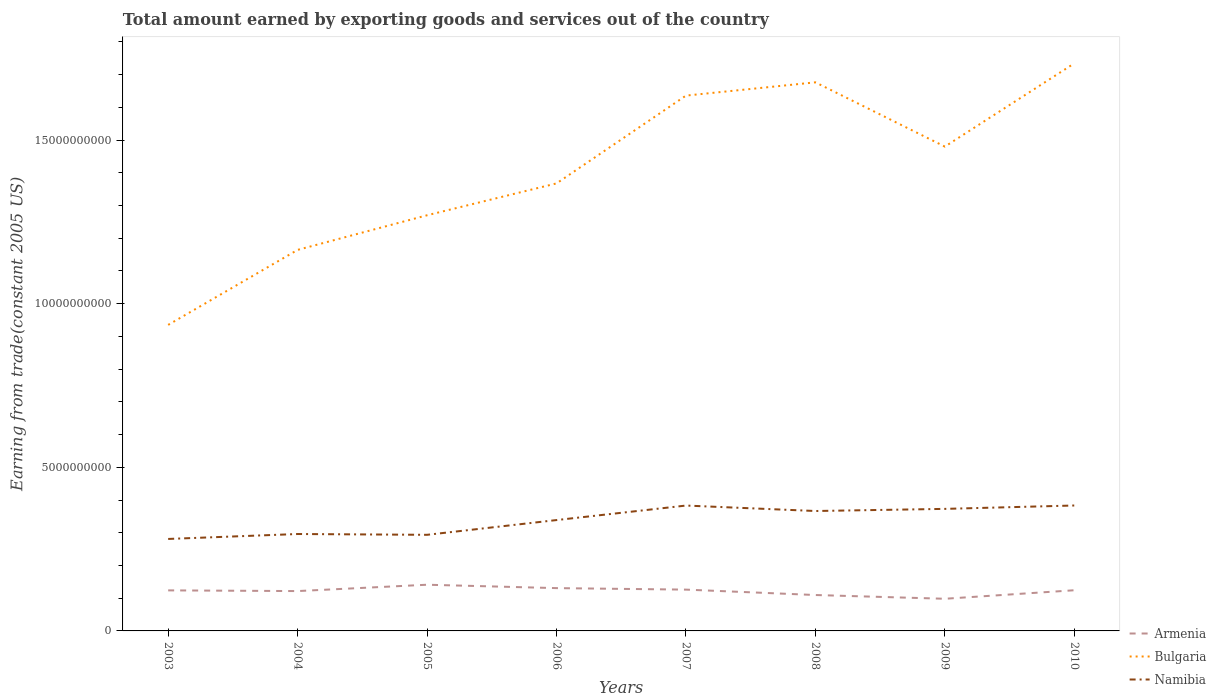How many different coloured lines are there?
Your answer should be compact. 3. Across all years, what is the maximum total amount earned by exporting goods and services in Bulgaria?
Your answer should be compact. 9.35e+09. What is the total total amount earned by exporting goods and services in Namibia in the graph?
Offer a very short reply. -4.51e+08. What is the difference between the highest and the second highest total amount earned by exporting goods and services in Namibia?
Give a very brief answer. 1.02e+09. What is the difference between the highest and the lowest total amount earned by exporting goods and services in Armenia?
Your answer should be compact. 5. How many lines are there?
Keep it short and to the point. 3. How many years are there in the graph?
Keep it short and to the point. 8. Does the graph contain any zero values?
Provide a short and direct response. No. Does the graph contain grids?
Provide a succinct answer. No. How many legend labels are there?
Offer a very short reply. 3. How are the legend labels stacked?
Your answer should be compact. Vertical. What is the title of the graph?
Give a very brief answer. Total amount earned by exporting goods and services out of the country. Does "San Marino" appear as one of the legend labels in the graph?
Your answer should be compact. No. What is the label or title of the X-axis?
Provide a succinct answer. Years. What is the label or title of the Y-axis?
Your answer should be very brief. Earning from trade(constant 2005 US). What is the Earning from trade(constant 2005 US) of Armenia in 2003?
Offer a terse response. 1.24e+09. What is the Earning from trade(constant 2005 US) of Bulgaria in 2003?
Provide a succinct answer. 9.35e+09. What is the Earning from trade(constant 2005 US) of Namibia in 2003?
Offer a very short reply. 2.81e+09. What is the Earning from trade(constant 2005 US) of Armenia in 2004?
Your answer should be very brief. 1.22e+09. What is the Earning from trade(constant 2005 US) of Bulgaria in 2004?
Make the answer very short. 1.16e+1. What is the Earning from trade(constant 2005 US) of Namibia in 2004?
Give a very brief answer. 2.96e+09. What is the Earning from trade(constant 2005 US) of Armenia in 2005?
Your response must be concise. 1.41e+09. What is the Earning from trade(constant 2005 US) in Bulgaria in 2005?
Make the answer very short. 1.27e+1. What is the Earning from trade(constant 2005 US) in Namibia in 2005?
Provide a short and direct response. 2.94e+09. What is the Earning from trade(constant 2005 US) of Armenia in 2006?
Offer a very short reply. 1.31e+09. What is the Earning from trade(constant 2005 US) of Bulgaria in 2006?
Keep it short and to the point. 1.37e+1. What is the Earning from trade(constant 2005 US) of Namibia in 2006?
Provide a short and direct response. 3.39e+09. What is the Earning from trade(constant 2005 US) of Armenia in 2007?
Provide a short and direct response. 1.26e+09. What is the Earning from trade(constant 2005 US) in Bulgaria in 2007?
Offer a very short reply. 1.64e+1. What is the Earning from trade(constant 2005 US) of Namibia in 2007?
Your response must be concise. 3.83e+09. What is the Earning from trade(constant 2005 US) in Armenia in 2008?
Provide a short and direct response. 1.10e+09. What is the Earning from trade(constant 2005 US) of Bulgaria in 2008?
Offer a very short reply. 1.68e+1. What is the Earning from trade(constant 2005 US) of Namibia in 2008?
Make the answer very short. 3.66e+09. What is the Earning from trade(constant 2005 US) in Armenia in 2009?
Provide a short and direct response. 9.83e+08. What is the Earning from trade(constant 2005 US) of Bulgaria in 2009?
Your answer should be very brief. 1.48e+1. What is the Earning from trade(constant 2005 US) of Namibia in 2009?
Provide a short and direct response. 3.73e+09. What is the Earning from trade(constant 2005 US) of Armenia in 2010?
Provide a short and direct response. 1.24e+09. What is the Earning from trade(constant 2005 US) in Bulgaria in 2010?
Make the answer very short. 1.73e+1. What is the Earning from trade(constant 2005 US) in Namibia in 2010?
Offer a terse response. 3.83e+09. Across all years, what is the maximum Earning from trade(constant 2005 US) of Armenia?
Keep it short and to the point. 1.41e+09. Across all years, what is the maximum Earning from trade(constant 2005 US) in Bulgaria?
Provide a succinct answer. 1.73e+1. Across all years, what is the maximum Earning from trade(constant 2005 US) in Namibia?
Offer a terse response. 3.83e+09. Across all years, what is the minimum Earning from trade(constant 2005 US) in Armenia?
Keep it short and to the point. 9.83e+08. Across all years, what is the minimum Earning from trade(constant 2005 US) in Bulgaria?
Offer a very short reply. 9.35e+09. Across all years, what is the minimum Earning from trade(constant 2005 US) of Namibia?
Provide a short and direct response. 2.81e+09. What is the total Earning from trade(constant 2005 US) of Armenia in the graph?
Your response must be concise. 9.76e+09. What is the total Earning from trade(constant 2005 US) of Bulgaria in the graph?
Give a very brief answer. 1.13e+11. What is the total Earning from trade(constant 2005 US) of Namibia in the graph?
Give a very brief answer. 2.72e+1. What is the difference between the Earning from trade(constant 2005 US) of Armenia in 2003 and that in 2004?
Your answer should be compact. 2.14e+07. What is the difference between the Earning from trade(constant 2005 US) in Bulgaria in 2003 and that in 2004?
Provide a succinct answer. -2.29e+09. What is the difference between the Earning from trade(constant 2005 US) in Namibia in 2003 and that in 2004?
Your answer should be compact. -1.51e+08. What is the difference between the Earning from trade(constant 2005 US) in Armenia in 2003 and that in 2005?
Your answer should be very brief. -1.73e+08. What is the difference between the Earning from trade(constant 2005 US) of Bulgaria in 2003 and that in 2005?
Offer a terse response. -3.35e+09. What is the difference between the Earning from trade(constant 2005 US) in Namibia in 2003 and that in 2005?
Your answer should be very brief. -1.26e+08. What is the difference between the Earning from trade(constant 2005 US) in Armenia in 2003 and that in 2006?
Give a very brief answer. -6.90e+07. What is the difference between the Earning from trade(constant 2005 US) in Bulgaria in 2003 and that in 2006?
Provide a succinct answer. -4.32e+09. What is the difference between the Earning from trade(constant 2005 US) in Namibia in 2003 and that in 2006?
Make the answer very short. -5.77e+08. What is the difference between the Earning from trade(constant 2005 US) in Armenia in 2003 and that in 2007?
Provide a succinct answer. -2.31e+07. What is the difference between the Earning from trade(constant 2005 US) of Bulgaria in 2003 and that in 2007?
Make the answer very short. -7.01e+09. What is the difference between the Earning from trade(constant 2005 US) of Namibia in 2003 and that in 2007?
Provide a succinct answer. -1.02e+09. What is the difference between the Earning from trade(constant 2005 US) in Armenia in 2003 and that in 2008?
Ensure brevity in your answer.  1.42e+08. What is the difference between the Earning from trade(constant 2005 US) in Bulgaria in 2003 and that in 2008?
Keep it short and to the point. -7.41e+09. What is the difference between the Earning from trade(constant 2005 US) in Namibia in 2003 and that in 2008?
Your answer should be compact. -8.54e+08. What is the difference between the Earning from trade(constant 2005 US) of Armenia in 2003 and that in 2009?
Provide a succinct answer. 2.56e+08. What is the difference between the Earning from trade(constant 2005 US) in Bulgaria in 2003 and that in 2009?
Offer a terse response. -5.45e+09. What is the difference between the Earning from trade(constant 2005 US) in Namibia in 2003 and that in 2009?
Offer a very short reply. -9.19e+08. What is the difference between the Earning from trade(constant 2005 US) of Armenia in 2003 and that in 2010?
Offer a very short reply. -3.95e+06. What is the difference between the Earning from trade(constant 2005 US) of Bulgaria in 2003 and that in 2010?
Provide a short and direct response. -7.99e+09. What is the difference between the Earning from trade(constant 2005 US) in Namibia in 2003 and that in 2010?
Your response must be concise. -1.02e+09. What is the difference between the Earning from trade(constant 2005 US) of Armenia in 2004 and that in 2005?
Give a very brief answer. -1.94e+08. What is the difference between the Earning from trade(constant 2005 US) of Bulgaria in 2004 and that in 2005?
Provide a succinct answer. -1.06e+09. What is the difference between the Earning from trade(constant 2005 US) in Namibia in 2004 and that in 2005?
Your response must be concise. 2.46e+07. What is the difference between the Earning from trade(constant 2005 US) in Armenia in 2004 and that in 2006?
Make the answer very short. -9.05e+07. What is the difference between the Earning from trade(constant 2005 US) of Bulgaria in 2004 and that in 2006?
Provide a short and direct response. -2.03e+09. What is the difference between the Earning from trade(constant 2005 US) in Namibia in 2004 and that in 2006?
Offer a terse response. -4.26e+08. What is the difference between the Earning from trade(constant 2005 US) of Armenia in 2004 and that in 2007?
Offer a very short reply. -4.46e+07. What is the difference between the Earning from trade(constant 2005 US) in Bulgaria in 2004 and that in 2007?
Provide a succinct answer. -4.72e+09. What is the difference between the Earning from trade(constant 2005 US) in Namibia in 2004 and that in 2007?
Your response must be concise. -8.70e+08. What is the difference between the Earning from trade(constant 2005 US) in Armenia in 2004 and that in 2008?
Keep it short and to the point. 1.21e+08. What is the difference between the Earning from trade(constant 2005 US) in Bulgaria in 2004 and that in 2008?
Your answer should be very brief. -5.12e+09. What is the difference between the Earning from trade(constant 2005 US) in Namibia in 2004 and that in 2008?
Offer a terse response. -7.03e+08. What is the difference between the Earning from trade(constant 2005 US) of Armenia in 2004 and that in 2009?
Your answer should be compact. 2.35e+08. What is the difference between the Earning from trade(constant 2005 US) in Bulgaria in 2004 and that in 2009?
Give a very brief answer. -3.16e+09. What is the difference between the Earning from trade(constant 2005 US) of Namibia in 2004 and that in 2009?
Make the answer very short. -7.68e+08. What is the difference between the Earning from trade(constant 2005 US) of Armenia in 2004 and that in 2010?
Offer a very short reply. -2.54e+07. What is the difference between the Earning from trade(constant 2005 US) of Bulgaria in 2004 and that in 2010?
Offer a very short reply. -5.70e+09. What is the difference between the Earning from trade(constant 2005 US) in Namibia in 2004 and that in 2010?
Offer a very short reply. -8.71e+08. What is the difference between the Earning from trade(constant 2005 US) of Armenia in 2005 and that in 2006?
Your answer should be very brief. 1.04e+08. What is the difference between the Earning from trade(constant 2005 US) in Bulgaria in 2005 and that in 2006?
Your response must be concise. -9.73e+08. What is the difference between the Earning from trade(constant 2005 US) of Namibia in 2005 and that in 2006?
Your answer should be compact. -4.51e+08. What is the difference between the Earning from trade(constant 2005 US) of Armenia in 2005 and that in 2007?
Offer a terse response. 1.50e+08. What is the difference between the Earning from trade(constant 2005 US) of Bulgaria in 2005 and that in 2007?
Offer a terse response. -3.66e+09. What is the difference between the Earning from trade(constant 2005 US) of Namibia in 2005 and that in 2007?
Make the answer very short. -8.94e+08. What is the difference between the Earning from trade(constant 2005 US) in Armenia in 2005 and that in 2008?
Make the answer very short. 3.15e+08. What is the difference between the Earning from trade(constant 2005 US) in Bulgaria in 2005 and that in 2008?
Provide a succinct answer. -4.06e+09. What is the difference between the Earning from trade(constant 2005 US) in Namibia in 2005 and that in 2008?
Keep it short and to the point. -7.27e+08. What is the difference between the Earning from trade(constant 2005 US) in Armenia in 2005 and that in 2009?
Your answer should be compact. 4.29e+08. What is the difference between the Earning from trade(constant 2005 US) in Bulgaria in 2005 and that in 2009?
Offer a terse response. -2.10e+09. What is the difference between the Earning from trade(constant 2005 US) of Namibia in 2005 and that in 2009?
Provide a succinct answer. -7.93e+08. What is the difference between the Earning from trade(constant 2005 US) of Armenia in 2005 and that in 2010?
Your answer should be very brief. 1.69e+08. What is the difference between the Earning from trade(constant 2005 US) in Bulgaria in 2005 and that in 2010?
Give a very brief answer. -4.64e+09. What is the difference between the Earning from trade(constant 2005 US) of Namibia in 2005 and that in 2010?
Make the answer very short. -8.96e+08. What is the difference between the Earning from trade(constant 2005 US) of Armenia in 2006 and that in 2007?
Your response must be concise. 4.59e+07. What is the difference between the Earning from trade(constant 2005 US) in Bulgaria in 2006 and that in 2007?
Your answer should be very brief. -2.68e+09. What is the difference between the Earning from trade(constant 2005 US) of Namibia in 2006 and that in 2007?
Your answer should be very brief. -4.44e+08. What is the difference between the Earning from trade(constant 2005 US) of Armenia in 2006 and that in 2008?
Offer a terse response. 2.11e+08. What is the difference between the Earning from trade(constant 2005 US) of Bulgaria in 2006 and that in 2008?
Provide a succinct answer. -3.09e+09. What is the difference between the Earning from trade(constant 2005 US) in Namibia in 2006 and that in 2008?
Provide a short and direct response. -2.77e+08. What is the difference between the Earning from trade(constant 2005 US) in Armenia in 2006 and that in 2009?
Give a very brief answer. 3.25e+08. What is the difference between the Earning from trade(constant 2005 US) in Bulgaria in 2006 and that in 2009?
Ensure brevity in your answer.  -1.12e+09. What is the difference between the Earning from trade(constant 2005 US) in Namibia in 2006 and that in 2009?
Give a very brief answer. -3.42e+08. What is the difference between the Earning from trade(constant 2005 US) of Armenia in 2006 and that in 2010?
Ensure brevity in your answer.  6.51e+07. What is the difference between the Earning from trade(constant 2005 US) of Bulgaria in 2006 and that in 2010?
Provide a succinct answer. -3.67e+09. What is the difference between the Earning from trade(constant 2005 US) in Namibia in 2006 and that in 2010?
Provide a short and direct response. -4.45e+08. What is the difference between the Earning from trade(constant 2005 US) in Armenia in 2007 and that in 2008?
Your answer should be compact. 1.65e+08. What is the difference between the Earning from trade(constant 2005 US) in Bulgaria in 2007 and that in 2008?
Offer a very short reply. -4.05e+08. What is the difference between the Earning from trade(constant 2005 US) in Namibia in 2007 and that in 2008?
Give a very brief answer. 1.67e+08. What is the difference between the Earning from trade(constant 2005 US) in Armenia in 2007 and that in 2009?
Provide a succinct answer. 2.80e+08. What is the difference between the Earning from trade(constant 2005 US) in Bulgaria in 2007 and that in 2009?
Provide a succinct answer. 1.56e+09. What is the difference between the Earning from trade(constant 2005 US) of Namibia in 2007 and that in 2009?
Offer a very short reply. 1.02e+08. What is the difference between the Earning from trade(constant 2005 US) in Armenia in 2007 and that in 2010?
Give a very brief answer. 1.92e+07. What is the difference between the Earning from trade(constant 2005 US) of Bulgaria in 2007 and that in 2010?
Offer a very short reply. -9.86e+08. What is the difference between the Earning from trade(constant 2005 US) of Namibia in 2007 and that in 2010?
Provide a short and direct response. -1.66e+06. What is the difference between the Earning from trade(constant 2005 US) in Armenia in 2008 and that in 2009?
Provide a succinct answer. 1.14e+08. What is the difference between the Earning from trade(constant 2005 US) of Bulgaria in 2008 and that in 2009?
Provide a short and direct response. 1.96e+09. What is the difference between the Earning from trade(constant 2005 US) in Namibia in 2008 and that in 2009?
Make the answer very short. -6.54e+07. What is the difference between the Earning from trade(constant 2005 US) in Armenia in 2008 and that in 2010?
Make the answer very short. -1.46e+08. What is the difference between the Earning from trade(constant 2005 US) in Bulgaria in 2008 and that in 2010?
Provide a succinct answer. -5.80e+08. What is the difference between the Earning from trade(constant 2005 US) of Namibia in 2008 and that in 2010?
Your response must be concise. -1.69e+08. What is the difference between the Earning from trade(constant 2005 US) in Armenia in 2009 and that in 2010?
Your response must be concise. -2.60e+08. What is the difference between the Earning from trade(constant 2005 US) of Bulgaria in 2009 and that in 2010?
Provide a succinct answer. -2.54e+09. What is the difference between the Earning from trade(constant 2005 US) of Namibia in 2009 and that in 2010?
Keep it short and to the point. -1.03e+08. What is the difference between the Earning from trade(constant 2005 US) of Armenia in 2003 and the Earning from trade(constant 2005 US) of Bulgaria in 2004?
Provide a short and direct response. -1.04e+1. What is the difference between the Earning from trade(constant 2005 US) of Armenia in 2003 and the Earning from trade(constant 2005 US) of Namibia in 2004?
Your answer should be very brief. -1.72e+09. What is the difference between the Earning from trade(constant 2005 US) of Bulgaria in 2003 and the Earning from trade(constant 2005 US) of Namibia in 2004?
Give a very brief answer. 6.39e+09. What is the difference between the Earning from trade(constant 2005 US) in Armenia in 2003 and the Earning from trade(constant 2005 US) in Bulgaria in 2005?
Provide a succinct answer. -1.15e+1. What is the difference between the Earning from trade(constant 2005 US) of Armenia in 2003 and the Earning from trade(constant 2005 US) of Namibia in 2005?
Offer a very short reply. -1.70e+09. What is the difference between the Earning from trade(constant 2005 US) of Bulgaria in 2003 and the Earning from trade(constant 2005 US) of Namibia in 2005?
Provide a succinct answer. 6.42e+09. What is the difference between the Earning from trade(constant 2005 US) of Armenia in 2003 and the Earning from trade(constant 2005 US) of Bulgaria in 2006?
Your answer should be very brief. -1.24e+1. What is the difference between the Earning from trade(constant 2005 US) in Armenia in 2003 and the Earning from trade(constant 2005 US) in Namibia in 2006?
Keep it short and to the point. -2.15e+09. What is the difference between the Earning from trade(constant 2005 US) in Bulgaria in 2003 and the Earning from trade(constant 2005 US) in Namibia in 2006?
Provide a short and direct response. 5.97e+09. What is the difference between the Earning from trade(constant 2005 US) of Armenia in 2003 and the Earning from trade(constant 2005 US) of Bulgaria in 2007?
Your response must be concise. -1.51e+1. What is the difference between the Earning from trade(constant 2005 US) of Armenia in 2003 and the Earning from trade(constant 2005 US) of Namibia in 2007?
Your response must be concise. -2.59e+09. What is the difference between the Earning from trade(constant 2005 US) in Bulgaria in 2003 and the Earning from trade(constant 2005 US) in Namibia in 2007?
Provide a short and direct response. 5.52e+09. What is the difference between the Earning from trade(constant 2005 US) in Armenia in 2003 and the Earning from trade(constant 2005 US) in Bulgaria in 2008?
Your answer should be very brief. -1.55e+1. What is the difference between the Earning from trade(constant 2005 US) of Armenia in 2003 and the Earning from trade(constant 2005 US) of Namibia in 2008?
Your response must be concise. -2.43e+09. What is the difference between the Earning from trade(constant 2005 US) in Bulgaria in 2003 and the Earning from trade(constant 2005 US) in Namibia in 2008?
Give a very brief answer. 5.69e+09. What is the difference between the Earning from trade(constant 2005 US) in Armenia in 2003 and the Earning from trade(constant 2005 US) in Bulgaria in 2009?
Offer a very short reply. -1.36e+1. What is the difference between the Earning from trade(constant 2005 US) of Armenia in 2003 and the Earning from trade(constant 2005 US) of Namibia in 2009?
Provide a short and direct response. -2.49e+09. What is the difference between the Earning from trade(constant 2005 US) in Bulgaria in 2003 and the Earning from trade(constant 2005 US) in Namibia in 2009?
Provide a succinct answer. 5.62e+09. What is the difference between the Earning from trade(constant 2005 US) of Armenia in 2003 and the Earning from trade(constant 2005 US) of Bulgaria in 2010?
Provide a short and direct response. -1.61e+1. What is the difference between the Earning from trade(constant 2005 US) in Armenia in 2003 and the Earning from trade(constant 2005 US) in Namibia in 2010?
Give a very brief answer. -2.59e+09. What is the difference between the Earning from trade(constant 2005 US) of Bulgaria in 2003 and the Earning from trade(constant 2005 US) of Namibia in 2010?
Your answer should be compact. 5.52e+09. What is the difference between the Earning from trade(constant 2005 US) in Armenia in 2004 and the Earning from trade(constant 2005 US) in Bulgaria in 2005?
Your answer should be compact. -1.15e+1. What is the difference between the Earning from trade(constant 2005 US) in Armenia in 2004 and the Earning from trade(constant 2005 US) in Namibia in 2005?
Offer a very short reply. -1.72e+09. What is the difference between the Earning from trade(constant 2005 US) of Bulgaria in 2004 and the Earning from trade(constant 2005 US) of Namibia in 2005?
Make the answer very short. 8.71e+09. What is the difference between the Earning from trade(constant 2005 US) of Armenia in 2004 and the Earning from trade(constant 2005 US) of Bulgaria in 2006?
Make the answer very short. -1.25e+1. What is the difference between the Earning from trade(constant 2005 US) of Armenia in 2004 and the Earning from trade(constant 2005 US) of Namibia in 2006?
Offer a terse response. -2.17e+09. What is the difference between the Earning from trade(constant 2005 US) in Bulgaria in 2004 and the Earning from trade(constant 2005 US) in Namibia in 2006?
Your answer should be compact. 8.26e+09. What is the difference between the Earning from trade(constant 2005 US) in Armenia in 2004 and the Earning from trade(constant 2005 US) in Bulgaria in 2007?
Your answer should be very brief. -1.51e+1. What is the difference between the Earning from trade(constant 2005 US) in Armenia in 2004 and the Earning from trade(constant 2005 US) in Namibia in 2007?
Make the answer very short. -2.61e+09. What is the difference between the Earning from trade(constant 2005 US) in Bulgaria in 2004 and the Earning from trade(constant 2005 US) in Namibia in 2007?
Provide a short and direct response. 7.81e+09. What is the difference between the Earning from trade(constant 2005 US) of Armenia in 2004 and the Earning from trade(constant 2005 US) of Bulgaria in 2008?
Offer a very short reply. -1.55e+1. What is the difference between the Earning from trade(constant 2005 US) in Armenia in 2004 and the Earning from trade(constant 2005 US) in Namibia in 2008?
Make the answer very short. -2.45e+09. What is the difference between the Earning from trade(constant 2005 US) of Bulgaria in 2004 and the Earning from trade(constant 2005 US) of Namibia in 2008?
Your answer should be compact. 7.98e+09. What is the difference between the Earning from trade(constant 2005 US) in Armenia in 2004 and the Earning from trade(constant 2005 US) in Bulgaria in 2009?
Your answer should be very brief. -1.36e+1. What is the difference between the Earning from trade(constant 2005 US) in Armenia in 2004 and the Earning from trade(constant 2005 US) in Namibia in 2009?
Give a very brief answer. -2.51e+09. What is the difference between the Earning from trade(constant 2005 US) in Bulgaria in 2004 and the Earning from trade(constant 2005 US) in Namibia in 2009?
Your response must be concise. 7.92e+09. What is the difference between the Earning from trade(constant 2005 US) of Armenia in 2004 and the Earning from trade(constant 2005 US) of Bulgaria in 2010?
Offer a terse response. -1.61e+1. What is the difference between the Earning from trade(constant 2005 US) in Armenia in 2004 and the Earning from trade(constant 2005 US) in Namibia in 2010?
Your answer should be compact. -2.62e+09. What is the difference between the Earning from trade(constant 2005 US) of Bulgaria in 2004 and the Earning from trade(constant 2005 US) of Namibia in 2010?
Offer a very short reply. 7.81e+09. What is the difference between the Earning from trade(constant 2005 US) in Armenia in 2005 and the Earning from trade(constant 2005 US) in Bulgaria in 2006?
Provide a succinct answer. -1.23e+1. What is the difference between the Earning from trade(constant 2005 US) in Armenia in 2005 and the Earning from trade(constant 2005 US) in Namibia in 2006?
Your answer should be very brief. -1.98e+09. What is the difference between the Earning from trade(constant 2005 US) of Bulgaria in 2005 and the Earning from trade(constant 2005 US) of Namibia in 2006?
Provide a short and direct response. 9.32e+09. What is the difference between the Earning from trade(constant 2005 US) in Armenia in 2005 and the Earning from trade(constant 2005 US) in Bulgaria in 2007?
Make the answer very short. -1.49e+1. What is the difference between the Earning from trade(constant 2005 US) in Armenia in 2005 and the Earning from trade(constant 2005 US) in Namibia in 2007?
Your answer should be very brief. -2.42e+09. What is the difference between the Earning from trade(constant 2005 US) of Bulgaria in 2005 and the Earning from trade(constant 2005 US) of Namibia in 2007?
Offer a very short reply. 8.87e+09. What is the difference between the Earning from trade(constant 2005 US) of Armenia in 2005 and the Earning from trade(constant 2005 US) of Bulgaria in 2008?
Ensure brevity in your answer.  -1.54e+1. What is the difference between the Earning from trade(constant 2005 US) in Armenia in 2005 and the Earning from trade(constant 2005 US) in Namibia in 2008?
Offer a terse response. -2.25e+09. What is the difference between the Earning from trade(constant 2005 US) of Bulgaria in 2005 and the Earning from trade(constant 2005 US) of Namibia in 2008?
Offer a terse response. 9.04e+09. What is the difference between the Earning from trade(constant 2005 US) in Armenia in 2005 and the Earning from trade(constant 2005 US) in Bulgaria in 2009?
Provide a succinct answer. -1.34e+1. What is the difference between the Earning from trade(constant 2005 US) in Armenia in 2005 and the Earning from trade(constant 2005 US) in Namibia in 2009?
Your answer should be compact. -2.32e+09. What is the difference between the Earning from trade(constant 2005 US) in Bulgaria in 2005 and the Earning from trade(constant 2005 US) in Namibia in 2009?
Give a very brief answer. 8.97e+09. What is the difference between the Earning from trade(constant 2005 US) of Armenia in 2005 and the Earning from trade(constant 2005 US) of Bulgaria in 2010?
Your answer should be very brief. -1.59e+1. What is the difference between the Earning from trade(constant 2005 US) of Armenia in 2005 and the Earning from trade(constant 2005 US) of Namibia in 2010?
Make the answer very short. -2.42e+09. What is the difference between the Earning from trade(constant 2005 US) in Bulgaria in 2005 and the Earning from trade(constant 2005 US) in Namibia in 2010?
Your response must be concise. 8.87e+09. What is the difference between the Earning from trade(constant 2005 US) of Armenia in 2006 and the Earning from trade(constant 2005 US) of Bulgaria in 2007?
Give a very brief answer. -1.51e+1. What is the difference between the Earning from trade(constant 2005 US) of Armenia in 2006 and the Earning from trade(constant 2005 US) of Namibia in 2007?
Offer a terse response. -2.52e+09. What is the difference between the Earning from trade(constant 2005 US) of Bulgaria in 2006 and the Earning from trade(constant 2005 US) of Namibia in 2007?
Ensure brevity in your answer.  9.85e+09. What is the difference between the Earning from trade(constant 2005 US) of Armenia in 2006 and the Earning from trade(constant 2005 US) of Bulgaria in 2008?
Keep it short and to the point. -1.55e+1. What is the difference between the Earning from trade(constant 2005 US) of Armenia in 2006 and the Earning from trade(constant 2005 US) of Namibia in 2008?
Offer a terse response. -2.36e+09. What is the difference between the Earning from trade(constant 2005 US) in Bulgaria in 2006 and the Earning from trade(constant 2005 US) in Namibia in 2008?
Make the answer very short. 1.00e+1. What is the difference between the Earning from trade(constant 2005 US) in Armenia in 2006 and the Earning from trade(constant 2005 US) in Bulgaria in 2009?
Provide a short and direct response. -1.35e+1. What is the difference between the Earning from trade(constant 2005 US) of Armenia in 2006 and the Earning from trade(constant 2005 US) of Namibia in 2009?
Provide a short and direct response. -2.42e+09. What is the difference between the Earning from trade(constant 2005 US) in Bulgaria in 2006 and the Earning from trade(constant 2005 US) in Namibia in 2009?
Offer a terse response. 9.95e+09. What is the difference between the Earning from trade(constant 2005 US) in Armenia in 2006 and the Earning from trade(constant 2005 US) in Bulgaria in 2010?
Ensure brevity in your answer.  -1.60e+1. What is the difference between the Earning from trade(constant 2005 US) in Armenia in 2006 and the Earning from trade(constant 2005 US) in Namibia in 2010?
Your answer should be compact. -2.52e+09. What is the difference between the Earning from trade(constant 2005 US) of Bulgaria in 2006 and the Earning from trade(constant 2005 US) of Namibia in 2010?
Make the answer very short. 9.84e+09. What is the difference between the Earning from trade(constant 2005 US) in Armenia in 2007 and the Earning from trade(constant 2005 US) in Bulgaria in 2008?
Make the answer very short. -1.55e+1. What is the difference between the Earning from trade(constant 2005 US) of Armenia in 2007 and the Earning from trade(constant 2005 US) of Namibia in 2008?
Keep it short and to the point. -2.40e+09. What is the difference between the Earning from trade(constant 2005 US) of Bulgaria in 2007 and the Earning from trade(constant 2005 US) of Namibia in 2008?
Offer a very short reply. 1.27e+1. What is the difference between the Earning from trade(constant 2005 US) in Armenia in 2007 and the Earning from trade(constant 2005 US) in Bulgaria in 2009?
Ensure brevity in your answer.  -1.35e+1. What is the difference between the Earning from trade(constant 2005 US) in Armenia in 2007 and the Earning from trade(constant 2005 US) in Namibia in 2009?
Make the answer very short. -2.47e+09. What is the difference between the Earning from trade(constant 2005 US) in Bulgaria in 2007 and the Earning from trade(constant 2005 US) in Namibia in 2009?
Your response must be concise. 1.26e+1. What is the difference between the Earning from trade(constant 2005 US) of Armenia in 2007 and the Earning from trade(constant 2005 US) of Bulgaria in 2010?
Your response must be concise. -1.61e+1. What is the difference between the Earning from trade(constant 2005 US) in Armenia in 2007 and the Earning from trade(constant 2005 US) in Namibia in 2010?
Offer a terse response. -2.57e+09. What is the difference between the Earning from trade(constant 2005 US) of Bulgaria in 2007 and the Earning from trade(constant 2005 US) of Namibia in 2010?
Your response must be concise. 1.25e+1. What is the difference between the Earning from trade(constant 2005 US) in Armenia in 2008 and the Earning from trade(constant 2005 US) in Bulgaria in 2009?
Your answer should be very brief. -1.37e+1. What is the difference between the Earning from trade(constant 2005 US) in Armenia in 2008 and the Earning from trade(constant 2005 US) in Namibia in 2009?
Keep it short and to the point. -2.63e+09. What is the difference between the Earning from trade(constant 2005 US) in Bulgaria in 2008 and the Earning from trade(constant 2005 US) in Namibia in 2009?
Your answer should be very brief. 1.30e+1. What is the difference between the Earning from trade(constant 2005 US) in Armenia in 2008 and the Earning from trade(constant 2005 US) in Bulgaria in 2010?
Make the answer very short. -1.62e+1. What is the difference between the Earning from trade(constant 2005 US) of Armenia in 2008 and the Earning from trade(constant 2005 US) of Namibia in 2010?
Provide a succinct answer. -2.74e+09. What is the difference between the Earning from trade(constant 2005 US) of Bulgaria in 2008 and the Earning from trade(constant 2005 US) of Namibia in 2010?
Offer a very short reply. 1.29e+1. What is the difference between the Earning from trade(constant 2005 US) of Armenia in 2009 and the Earning from trade(constant 2005 US) of Bulgaria in 2010?
Give a very brief answer. -1.64e+1. What is the difference between the Earning from trade(constant 2005 US) in Armenia in 2009 and the Earning from trade(constant 2005 US) in Namibia in 2010?
Ensure brevity in your answer.  -2.85e+09. What is the difference between the Earning from trade(constant 2005 US) in Bulgaria in 2009 and the Earning from trade(constant 2005 US) in Namibia in 2010?
Your response must be concise. 1.10e+1. What is the average Earning from trade(constant 2005 US) of Armenia per year?
Your answer should be compact. 1.22e+09. What is the average Earning from trade(constant 2005 US) in Bulgaria per year?
Ensure brevity in your answer.  1.41e+1. What is the average Earning from trade(constant 2005 US) in Namibia per year?
Ensure brevity in your answer.  3.39e+09. In the year 2003, what is the difference between the Earning from trade(constant 2005 US) in Armenia and Earning from trade(constant 2005 US) in Bulgaria?
Your response must be concise. -8.11e+09. In the year 2003, what is the difference between the Earning from trade(constant 2005 US) in Armenia and Earning from trade(constant 2005 US) in Namibia?
Make the answer very short. -1.57e+09. In the year 2003, what is the difference between the Earning from trade(constant 2005 US) in Bulgaria and Earning from trade(constant 2005 US) in Namibia?
Your response must be concise. 6.54e+09. In the year 2004, what is the difference between the Earning from trade(constant 2005 US) of Armenia and Earning from trade(constant 2005 US) of Bulgaria?
Ensure brevity in your answer.  -1.04e+1. In the year 2004, what is the difference between the Earning from trade(constant 2005 US) in Armenia and Earning from trade(constant 2005 US) in Namibia?
Give a very brief answer. -1.74e+09. In the year 2004, what is the difference between the Earning from trade(constant 2005 US) in Bulgaria and Earning from trade(constant 2005 US) in Namibia?
Your response must be concise. 8.68e+09. In the year 2005, what is the difference between the Earning from trade(constant 2005 US) of Armenia and Earning from trade(constant 2005 US) of Bulgaria?
Ensure brevity in your answer.  -1.13e+1. In the year 2005, what is the difference between the Earning from trade(constant 2005 US) of Armenia and Earning from trade(constant 2005 US) of Namibia?
Provide a succinct answer. -1.53e+09. In the year 2005, what is the difference between the Earning from trade(constant 2005 US) of Bulgaria and Earning from trade(constant 2005 US) of Namibia?
Ensure brevity in your answer.  9.77e+09. In the year 2006, what is the difference between the Earning from trade(constant 2005 US) of Armenia and Earning from trade(constant 2005 US) of Bulgaria?
Provide a succinct answer. -1.24e+1. In the year 2006, what is the difference between the Earning from trade(constant 2005 US) in Armenia and Earning from trade(constant 2005 US) in Namibia?
Your response must be concise. -2.08e+09. In the year 2006, what is the difference between the Earning from trade(constant 2005 US) of Bulgaria and Earning from trade(constant 2005 US) of Namibia?
Your answer should be very brief. 1.03e+1. In the year 2007, what is the difference between the Earning from trade(constant 2005 US) of Armenia and Earning from trade(constant 2005 US) of Bulgaria?
Provide a short and direct response. -1.51e+1. In the year 2007, what is the difference between the Earning from trade(constant 2005 US) of Armenia and Earning from trade(constant 2005 US) of Namibia?
Provide a succinct answer. -2.57e+09. In the year 2007, what is the difference between the Earning from trade(constant 2005 US) in Bulgaria and Earning from trade(constant 2005 US) in Namibia?
Offer a very short reply. 1.25e+1. In the year 2008, what is the difference between the Earning from trade(constant 2005 US) of Armenia and Earning from trade(constant 2005 US) of Bulgaria?
Your answer should be very brief. -1.57e+1. In the year 2008, what is the difference between the Earning from trade(constant 2005 US) of Armenia and Earning from trade(constant 2005 US) of Namibia?
Ensure brevity in your answer.  -2.57e+09. In the year 2008, what is the difference between the Earning from trade(constant 2005 US) in Bulgaria and Earning from trade(constant 2005 US) in Namibia?
Your answer should be very brief. 1.31e+1. In the year 2009, what is the difference between the Earning from trade(constant 2005 US) of Armenia and Earning from trade(constant 2005 US) of Bulgaria?
Give a very brief answer. -1.38e+1. In the year 2009, what is the difference between the Earning from trade(constant 2005 US) in Armenia and Earning from trade(constant 2005 US) in Namibia?
Ensure brevity in your answer.  -2.75e+09. In the year 2009, what is the difference between the Earning from trade(constant 2005 US) in Bulgaria and Earning from trade(constant 2005 US) in Namibia?
Offer a terse response. 1.11e+1. In the year 2010, what is the difference between the Earning from trade(constant 2005 US) in Armenia and Earning from trade(constant 2005 US) in Bulgaria?
Provide a succinct answer. -1.61e+1. In the year 2010, what is the difference between the Earning from trade(constant 2005 US) in Armenia and Earning from trade(constant 2005 US) in Namibia?
Offer a terse response. -2.59e+09. In the year 2010, what is the difference between the Earning from trade(constant 2005 US) in Bulgaria and Earning from trade(constant 2005 US) in Namibia?
Ensure brevity in your answer.  1.35e+1. What is the ratio of the Earning from trade(constant 2005 US) of Armenia in 2003 to that in 2004?
Offer a very short reply. 1.02. What is the ratio of the Earning from trade(constant 2005 US) of Bulgaria in 2003 to that in 2004?
Offer a terse response. 0.8. What is the ratio of the Earning from trade(constant 2005 US) in Namibia in 2003 to that in 2004?
Your answer should be compact. 0.95. What is the ratio of the Earning from trade(constant 2005 US) of Armenia in 2003 to that in 2005?
Ensure brevity in your answer.  0.88. What is the ratio of the Earning from trade(constant 2005 US) in Bulgaria in 2003 to that in 2005?
Your answer should be compact. 0.74. What is the ratio of the Earning from trade(constant 2005 US) in Namibia in 2003 to that in 2005?
Provide a succinct answer. 0.96. What is the ratio of the Earning from trade(constant 2005 US) of Armenia in 2003 to that in 2006?
Provide a short and direct response. 0.95. What is the ratio of the Earning from trade(constant 2005 US) of Bulgaria in 2003 to that in 2006?
Your answer should be very brief. 0.68. What is the ratio of the Earning from trade(constant 2005 US) of Namibia in 2003 to that in 2006?
Your answer should be very brief. 0.83. What is the ratio of the Earning from trade(constant 2005 US) of Armenia in 2003 to that in 2007?
Your answer should be very brief. 0.98. What is the ratio of the Earning from trade(constant 2005 US) of Bulgaria in 2003 to that in 2007?
Give a very brief answer. 0.57. What is the ratio of the Earning from trade(constant 2005 US) of Namibia in 2003 to that in 2007?
Make the answer very short. 0.73. What is the ratio of the Earning from trade(constant 2005 US) of Armenia in 2003 to that in 2008?
Provide a succinct answer. 1.13. What is the ratio of the Earning from trade(constant 2005 US) of Bulgaria in 2003 to that in 2008?
Your answer should be compact. 0.56. What is the ratio of the Earning from trade(constant 2005 US) of Namibia in 2003 to that in 2008?
Make the answer very short. 0.77. What is the ratio of the Earning from trade(constant 2005 US) of Armenia in 2003 to that in 2009?
Offer a terse response. 1.26. What is the ratio of the Earning from trade(constant 2005 US) of Bulgaria in 2003 to that in 2009?
Your answer should be compact. 0.63. What is the ratio of the Earning from trade(constant 2005 US) of Namibia in 2003 to that in 2009?
Offer a very short reply. 0.75. What is the ratio of the Earning from trade(constant 2005 US) of Bulgaria in 2003 to that in 2010?
Provide a short and direct response. 0.54. What is the ratio of the Earning from trade(constant 2005 US) in Namibia in 2003 to that in 2010?
Give a very brief answer. 0.73. What is the ratio of the Earning from trade(constant 2005 US) of Armenia in 2004 to that in 2005?
Your answer should be very brief. 0.86. What is the ratio of the Earning from trade(constant 2005 US) in Bulgaria in 2004 to that in 2005?
Keep it short and to the point. 0.92. What is the ratio of the Earning from trade(constant 2005 US) of Namibia in 2004 to that in 2005?
Give a very brief answer. 1.01. What is the ratio of the Earning from trade(constant 2005 US) in Armenia in 2004 to that in 2006?
Give a very brief answer. 0.93. What is the ratio of the Earning from trade(constant 2005 US) in Bulgaria in 2004 to that in 2006?
Your answer should be compact. 0.85. What is the ratio of the Earning from trade(constant 2005 US) in Namibia in 2004 to that in 2006?
Your answer should be very brief. 0.87. What is the ratio of the Earning from trade(constant 2005 US) in Armenia in 2004 to that in 2007?
Provide a succinct answer. 0.96. What is the ratio of the Earning from trade(constant 2005 US) of Bulgaria in 2004 to that in 2007?
Provide a short and direct response. 0.71. What is the ratio of the Earning from trade(constant 2005 US) in Namibia in 2004 to that in 2007?
Make the answer very short. 0.77. What is the ratio of the Earning from trade(constant 2005 US) in Armenia in 2004 to that in 2008?
Offer a very short reply. 1.11. What is the ratio of the Earning from trade(constant 2005 US) of Bulgaria in 2004 to that in 2008?
Give a very brief answer. 0.69. What is the ratio of the Earning from trade(constant 2005 US) of Namibia in 2004 to that in 2008?
Ensure brevity in your answer.  0.81. What is the ratio of the Earning from trade(constant 2005 US) in Armenia in 2004 to that in 2009?
Your response must be concise. 1.24. What is the ratio of the Earning from trade(constant 2005 US) of Bulgaria in 2004 to that in 2009?
Your response must be concise. 0.79. What is the ratio of the Earning from trade(constant 2005 US) of Namibia in 2004 to that in 2009?
Ensure brevity in your answer.  0.79. What is the ratio of the Earning from trade(constant 2005 US) in Armenia in 2004 to that in 2010?
Offer a very short reply. 0.98. What is the ratio of the Earning from trade(constant 2005 US) in Bulgaria in 2004 to that in 2010?
Ensure brevity in your answer.  0.67. What is the ratio of the Earning from trade(constant 2005 US) of Namibia in 2004 to that in 2010?
Make the answer very short. 0.77. What is the ratio of the Earning from trade(constant 2005 US) of Armenia in 2005 to that in 2006?
Ensure brevity in your answer.  1.08. What is the ratio of the Earning from trade(constant 2005 US) in Bulgaria in 2005 to that in 2006?
Offer a very short reply. 0.93. What is the ratio of the Earning from trade(constant 2005 US) in Namibia in 2005 to that in 2006?
Provide a short and direct response. 0.87. What is the ratio of the Earning from trade(constant 2005 US) of Armenia in 2005 to that in 2007?
Give a very brief answer. 1.12. What is the ratio of the Earning from trade(constant 2005 US) in Bulgaria in 2005 to that in 2007?
Your answer should be compact. 0.78. What is the ratio of the Earning from trade(constant 2005 US) of Namibia in 2005 to that in 2007?
Your response must be concise. 0.77. What is the ratio of the Earning from trade(constant 2005 US) of Armenia in 2005 to that in 2008?
Give a very brief answer. 1.29. What is the ratio of the Earning from trade(constant 2005 US) in Bulgaria in 2005 to that in 2008?
Your response must be concise. 0.76. What is the ratio of the Earning from trade(constant 2005 US) in Namibia in 2005 to that in 2008?
Provide a succinct answer. 0.8. What is the ratio of the Earning from trade(constant 2005 US) of Armenia in 2005 to that in 2009?
Keep it short and to the point. 1.44. What is the ratio of the Earning from trade(constant 2005 US) of Bulgaria in 2005 to that in 2009?
Your response must be concise. 0.86. What is the ratio of the Earning from trade(constant 2005 US) of Namibia in 2005 to that in 2009?
Your answer should be very brief. 0.79. What is the ratio of the Earning from trade(constant 2005 US) in Armenia in 2005 to that in 2010?
Offer a very short reply. 1.14. What is the ratio of the Earning from trade(constant 2005 US) in Bulgaria in 2005 to that in 2010?
Give a very brief answer. 0.73. What is the ratio of the Earning from trade(constant 2005 US) of Namibia in 2005 to that in 2010?
Give a very brief answer. 0.77. What is the ratio of the Earning from trade(constant 2005 US) of Armenia in 2006 to that in 2007?
Your answer should be very brief. 1.04. What is the ratio of the Earning from trade(constant 2005 US) in Bulgaria in 2006 to that in 2007?
Your answer should be very brief. 0.84. What is the ratio of the Earning from trade(constant 2005 US) of Namibia in 2006 to that in 2007?
Make the answer very short. 0.88. What is the ratio of the Earning from trade(constant 2005 US) in Armenia in 2006 to that in 2008?
Your answer should be compact. 1.19. What is the ratio of the Earning from trade(constant 2005 US) of Bulgaria in 2006 to that in 2008?
Give a very brief answer. 0.82. What is the ratio of the Earning from trade(constant 2005 US) in Namibia in 2006 to that in 2008?
Give a very brief answer. 0.92. What is the ratio of the Earning from trade(constant 2005 US) in Armenia in 2006 to that in 2009?
Keep it short and to the point. 1.33. What is the ratio of the Earning from trade(constant 2005 US) of Bulgaria in 2006 to that in 2009?
Offer a terse response. 0.92. What is the ratio of the Earning from trade(constant 2005 US) in Namibia in 2006 to that in 2009?
Offer a terse response. 0.91. What is the ratio of the Earning from trade(constant 2005 US) in Armenia in 2006 to that in 2010?
Your answer should be very brief. 1.05. What is the ratio of the Earning from trade(constant 2005 US) in Bulgaria in 2006 to that in 2010?
Give a very brief answer. 0.79. What is the ratio of the Earning from trade(constant 2005 US) of Namibia in 2006 to that in 2010?
Your response must be concise. 0.88. What is the ratio of the Earning from trade(constant 2005 US) in Armenia in 2007 to that in 2008?
Provide a short and direct response. 1.15. What is the ratio of the Earning from trade(constant 2005 US) of Bulgaria in 2007 to that in 2008?
Make the answer very short. 0.98. What is the ratio of the Earning from trade(constant 2005 US) of Namibia in 2007 to that in 2008?
Make the answer very short. 1.05. What is the ratio of the Earning from trade(constant 2005 US) in Armenia in 2007 to that in 2009?
Provide a succinct answer. 1.28. What is the ratio of the Earning from trade(constant 2005 US) of Bulgaria in 2007 to that in 2009?
Your answer should be very brief. 1.11. What is the ratio of the Earning from trade(constant 2005 US) in Namibia in 2007 to that in 2009?
Your answer should be compact. 1.03. What is the ratio of the Earning from trade(constant 2005 US) of Armenia in 2007 to that in 2010?
Keep it short and to the point. 1.02. What is the ratio of the Earning from trade(constant 2005 US) of Bulgaria in 2007 to that in 2010?
Make the answer very short. 0.94. What is the ratio of the Earning from trade(constant 2005 US) of Namibia in 2007 to that in 2010?
Your answer should be compact. 1. What is the ratio of the Earning from trade(constant 2005 US) in Armenia in 2008 to that in 2009?
Offer a very short reply. 1.12. What is the ratio of the Earning from trade(constant 2005 US) in Bulgaria in 2008 to that in 2009?
Offer a very short reply. 1.13. What is the ratio of the Earning from trade(constant 2005 US) in Namibia in 2008 to that in 2009?
Give a very brief answer. 0.98. What is the ratio of the Earning from trade(constant 2005 US) in Armenia in 2008 to that in 2010?
Make the answer very short. 0.88. What is the ratio of the Earning from trade(constant 2005 US) in Bulgaria in 2008 to that in 2010?
Make the answer very short. 0.97. What is the ratio of the Earning from trade(constant 2005 US) in Namibia in 2008 to that in 2010?
Your answer should be compact. 0.96. What is the ratio of the Earning from trade(constant 2005 US) in Armenia in 2009 to that in 2010?
Your answer should be compact. 0.79. What is the ratio of the Earning from trade(constant 2005 US) in Bulgaria in 2009 to that in 2010?
Ensure brevity in your answer.  0.85. What is the ratio of the Earning from trade(constant 2005 US) of Namibia in 2009 to that in 2010?
Provide a succinct answer. 0.97. What is the difference between the highest and the second highest Earning from trade(constant 2005 US) of Armenia?
Your answer should be very brief. 1.04e+08. What is the difference between the highest and the second highest Earning from trade(constant 2005 US) in Bulgaria?
Keep it short and to the point. 5.80e+08. What is the difference between the highest and the second highest Earning from trade(constant 2005 US) of Namibia?
Ensure brevity in your answer.  1.66e+06. What is the difference between the highest and the lowest Earning from trade(constant 2005 US) of Armenia?
Provide a short and direct response. 4.29e+08. What is the difference between the highest and the lowest Earning from trade(constant 2005 US) of Bulgaria?
Offer a very short reply. 7.99e+09. What is the difference between the highest and the lowest Earning from trade(constant 2005 US) in Namibia?
Make the answer very short. 1.02e+09. 